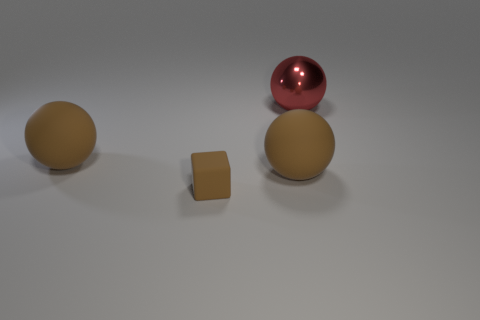How are the objects arranged in relation to each other? The objects are placed on a flat surface with the two larger spheres positioned on either side and slightly behind a smaller brown cube in the center. 